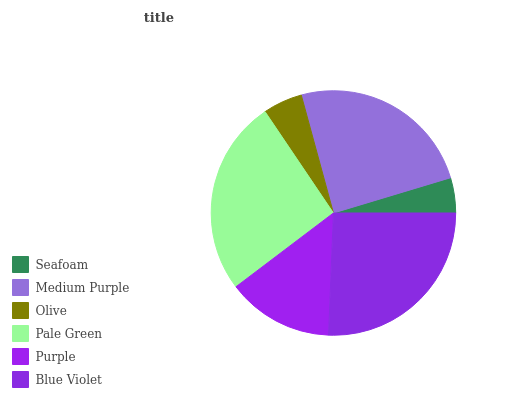Is Seafoam the minimum?
Answer yes or no. Yes. Is Pale Green the maximum?
Answer yes or no. Yes. Is Medium Purple the minimum?
Answer yes or no. No. Is Medium Purple the maximum?
Answer yes or no. No. Is Medium Purple greater than Seafoam?
Answer yes or no. Yes. Is Seafoam less than Medium Purple?
Answer yes or no. Yes. Is Seafoam greater than Medium Purple?
Answer yes or no. No. Is Medium Purple less than Seafoam?
Answer yes or no. No. Is Medium Purple the high median?
Answer yes or no. Yes. Is Purple the low median?
Answer yes or no. Yes. Is Pale Green the high median?
Answer yes or no. No. Is Medium Purple the low median?
Answer yes or no. No. 